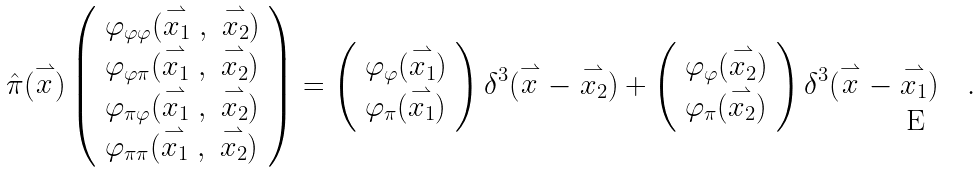<formula> <loc_0><loc_0><loc_500><loc_500>\hat { \pi } ( \stackrel { \rightharpoonup } { x } ) \left ( \begin{array} { l } \varphi _ { \varphi \varphi } ( \stackrel { \rightharpoonup } { x _ { 1 } } \ , \ \stackrel { \rightharpoonup } { x _ { 2 } } ) \\ \varphi _ { \varphi \pi } ( \stackrel { \rightharpoonup } { x _ { 1 } } \ , \ \stackrel { \rightharpoonup } { x _ { 2 } } ) \\ \varphi _ { \pi \varphi } ( \stackrel { \rightharpoonup } { x _ { 1 } } \ , \ \stackrel { \rightharpoonup } { x _ { 2 } } ) \\ \varphi _ { \pi \pi } ( \stackrel { \rightharpoonup } { x _ { 1 } } \ , \ \stackrel { \rightharpoonup } { x _ { 2 } } ) \end{array} \right ) = \left ( \begin{array} { l } \varphi _ { \varphi } ( \stackrel { \rightharpoonup } { x _ { 1 } } ) \\ \varphi _ { \pi } ( \stackrel { \rightharpoonup } { x _ { 1 } } ) \end{array} \right ) \delta ^ { 3 } ( \stackrel { \rightharpoonup } { x } - \stackrel { \rightharpoonup } { x _ { 2 } } ) + \left ( \begin{array} { l } \varphi _ { \varphi } ( \stackrel { \rightharpoonup } { x _ { 2 } } ) \\ \varphi _ { \pi } ( \stackrel { \rightharpoonup } { x _ { 2 } } ) \end{array} \right ) \delta ^ { 3 } ( \stackrel { \rightharpoonup } { x } - \stackrel { \rightharpoonup } { x _ { 1 } } ) \quad .</formula> 